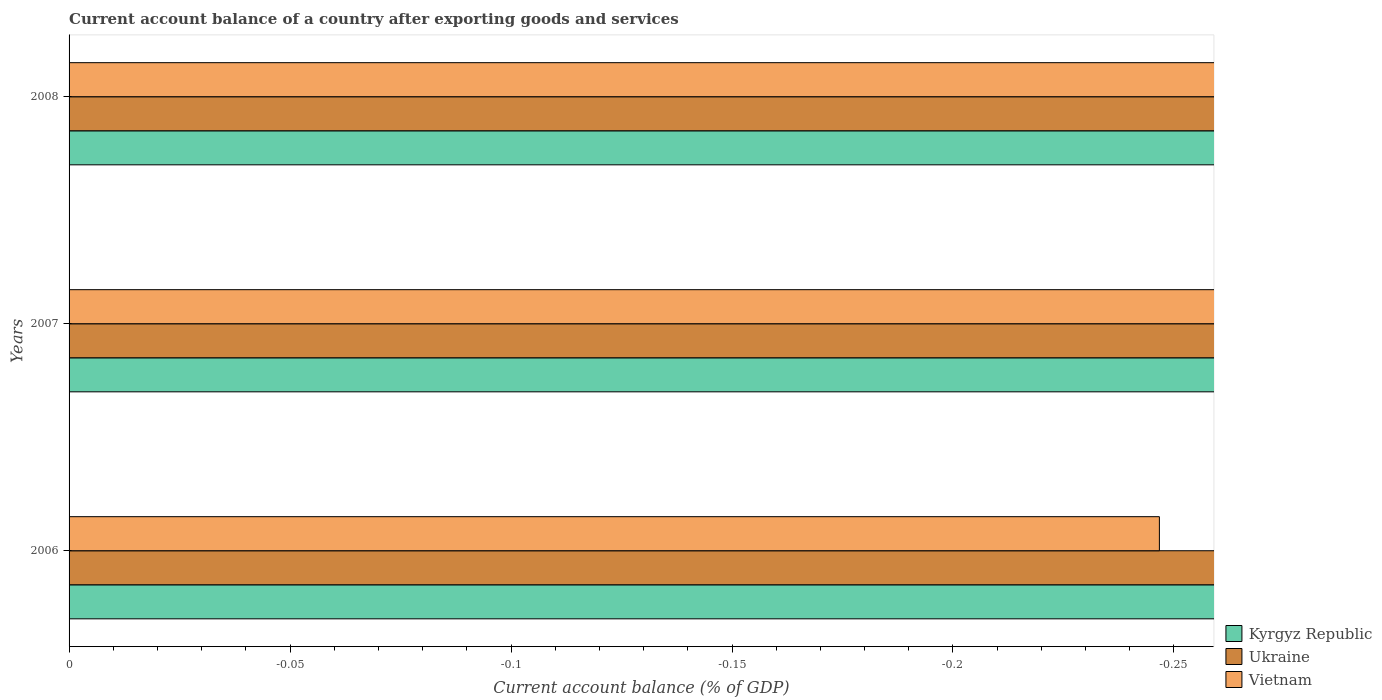How many bars are there on the 1st tick from the top?
Keep it short and to the point. 0. Across all years, what is the minimum account balance in Kyrgyz Republic?
Provide a short and direct response. 0. What is the total account balance in Vietnam in the graph?
Offer a very short reply. 0. What is the average account balance in Vietnam per year?
Ensure brevity in your answer.  0. In how many years, is the account balance in Kyrgyz Republic greater than the average account balance in Kyrgyz Republic taken over all years?
Provide a succinct answer. 0. How many bars are there?
Make the answer very short. 0. Are all the bars in the graph horizontal?
Make the answer very short. Yes. How many years are there in the graph?
Make the answer very short. 3. What is the difference between two consecutive major ticks on the X-axis?
Keep it short and to the point. 0.05. Are the values on the major ticks of X-axis written in scientific E-notation?
Your answer should be very brief. No. Does the graph contain any zero values?
Provide a succinct answer. Yes. How many legend labels are there?
Give a very brief answer. 3. How are the legend labels stacked?
Provide a short and direct response. Vertical. What is the title of the graph?
Provide a succinct answer. Current account balance of a country after exporting goods and services. What is the label or title of the X-axis?
Make the answer very short. Current account balance (% of GDP). What is the Current account balance (% of GDP) of Vietnam in 2006?
Keep it short and to the point. 0. What is the Current account balance (% of GDP) of Kyrgyz Republic in 2007?
Make the answer very short. 0. What is the Current account balance (% of GDP) of Ukraine in 2008?
Ensure brevity in your answer.  0. What is the Current account balance (% of GDP) of Vietnam in 2008?
Offer a very short reply. 0. What is the total Current account balance (% of GDP) of Kyrgyz Republic in the graph?
Your answer should be very brief. 0. What is the total Current account balance (% of GDP) in Vietnam in the graph?
Offer a terse response. 0. What is the average Current account balance (% of GDP) in Kyrgyz Republic per year?
Provide a succinct answer. 0. 